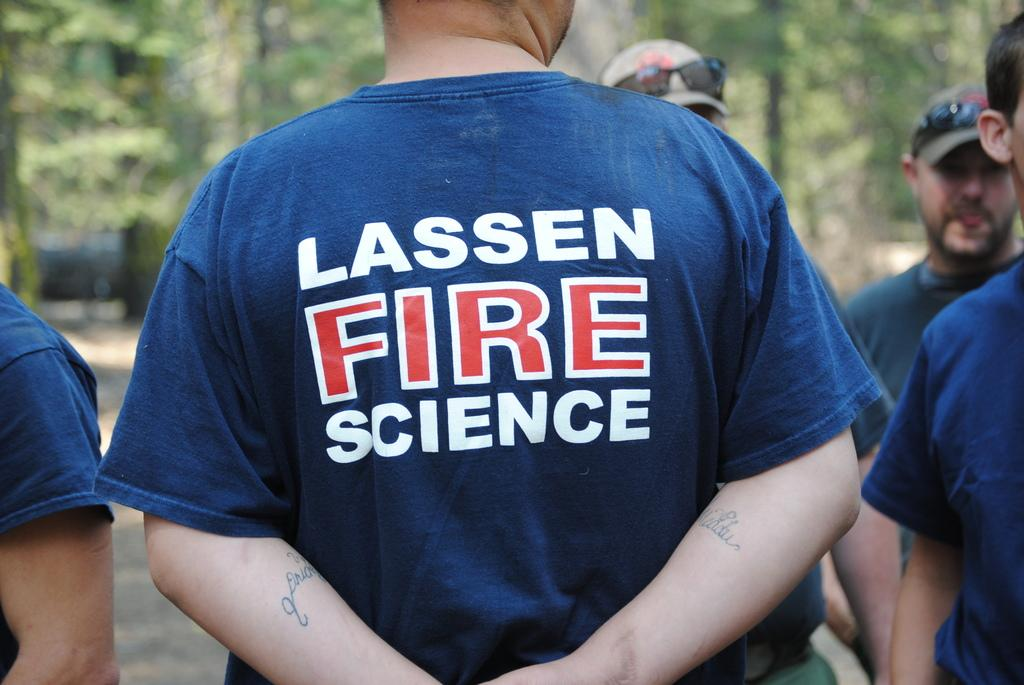<image>
Write a terse but informative summary of the picture. a group of men wearing Lassen Fire Science tshirts 